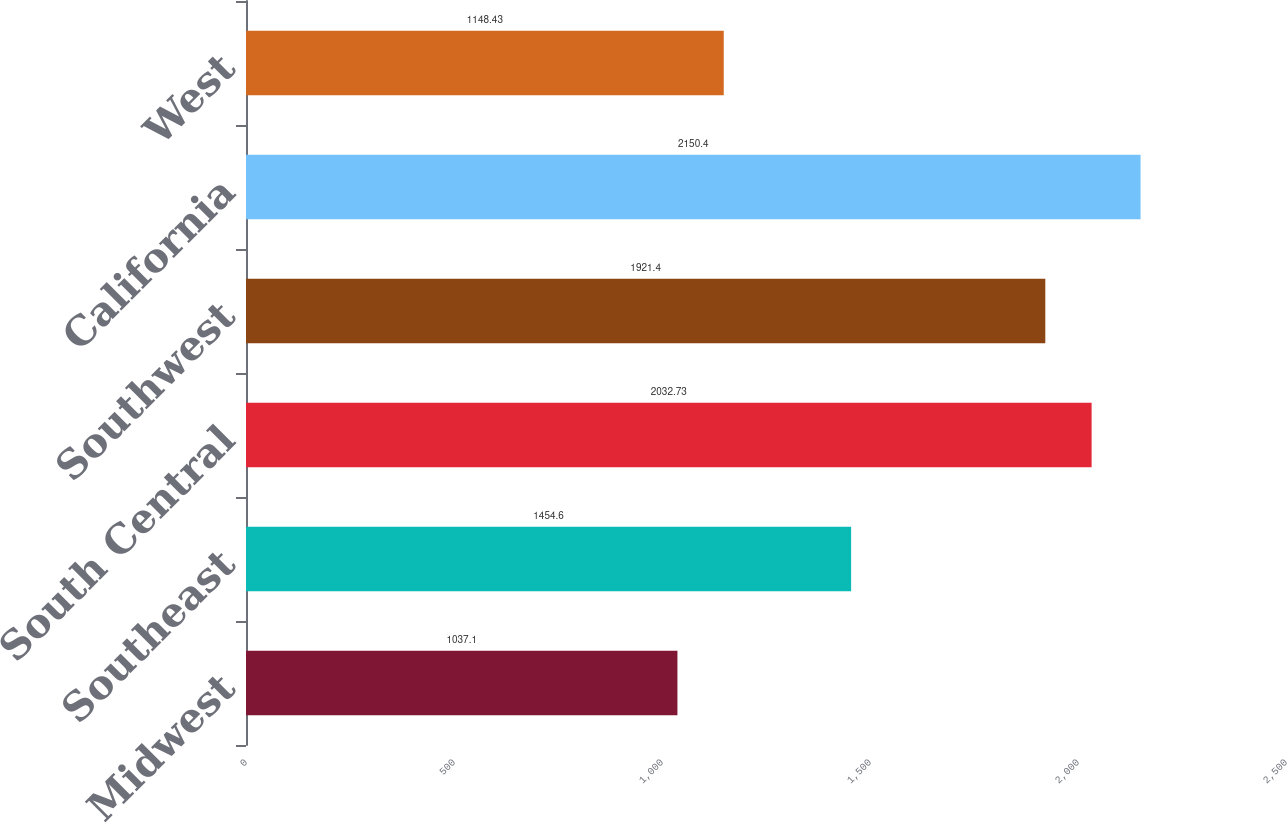Convert chart to OTSL. <chart><loc_0><loc_0><loc_500><loc_500><bar_chart><fcel>Midwest<fcel>Southeast<fcel>South Central<fcel>Southwest<fcel>California<fcel>West<nl><fcel>1037.1<fcel>1454.6<fcel>2032.73<fcel>1921.4<fcel>2150.4<fcel>1148.43<nl></chart> 